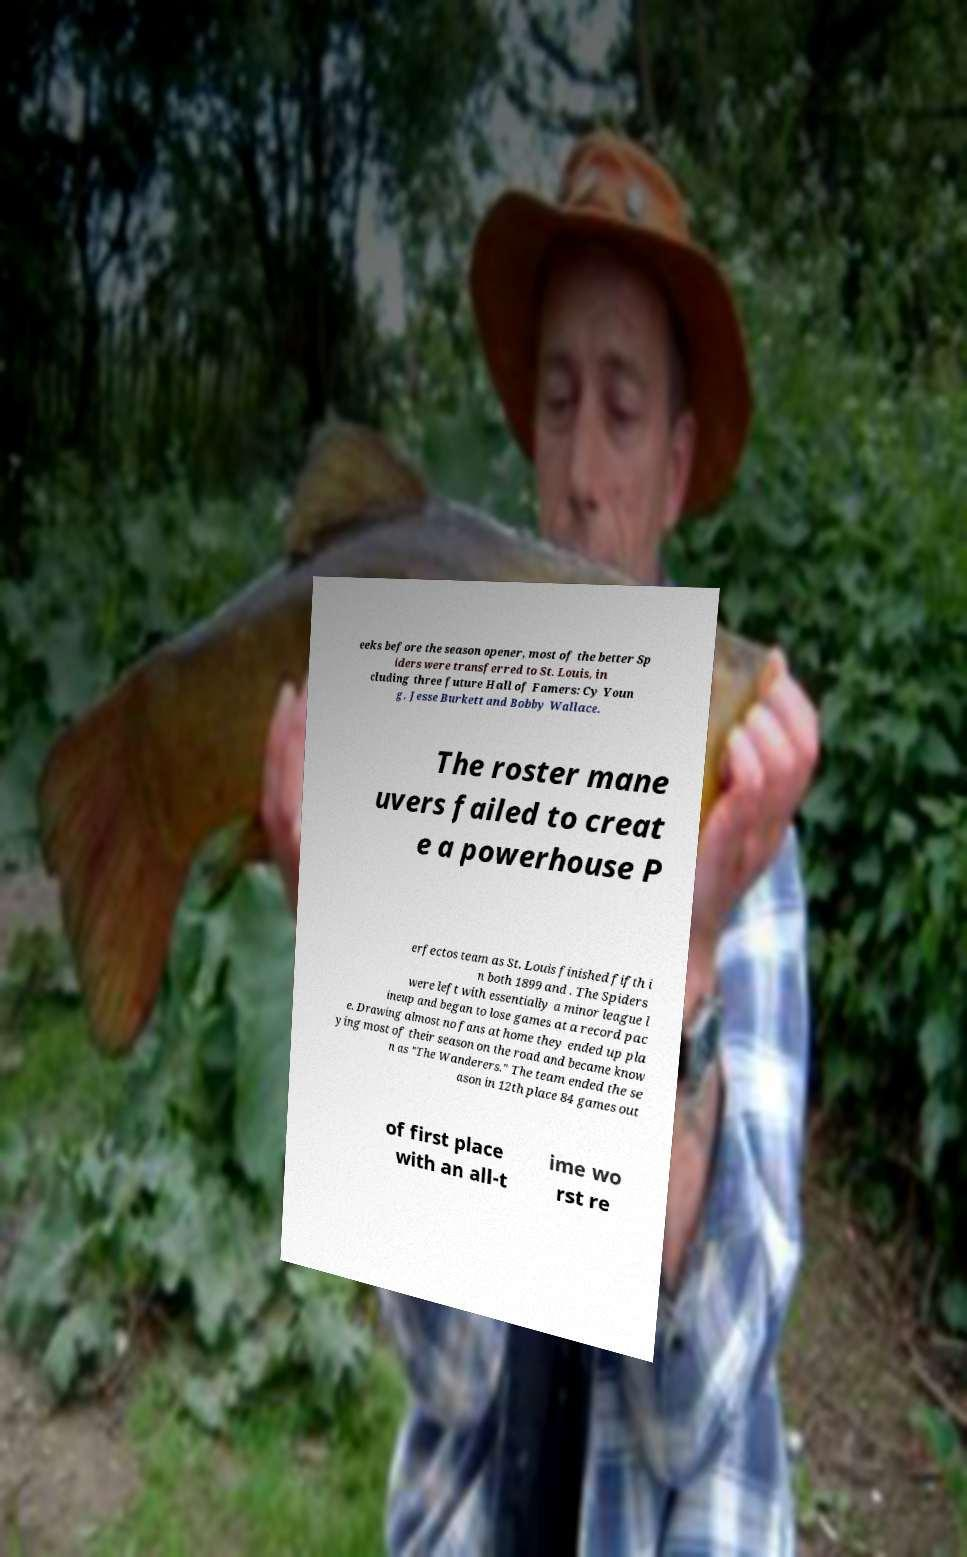Can you accurately transcribe the text from the provided image for me? eeks before the season opener, most of the better Sp iders were transferred to St. Louis, in cluding three future Hall of Famers: Cy Youn g, Jesse Burkett and Bobby Wallace. The roster mane uvers failed to creat e a powerhouse P erfectos team as St. Louis finished fifth i n both 1899 and . The Spiders were left with essentially a minor league l ineup and began to lose games at a record pac e. Drawing almost no fans at home they ended up pla ying most of their season on the road and became know n as "The Wanderers." The team ended the se ason in 12th place 84 games out of first place with an all-t ime wo rst re 